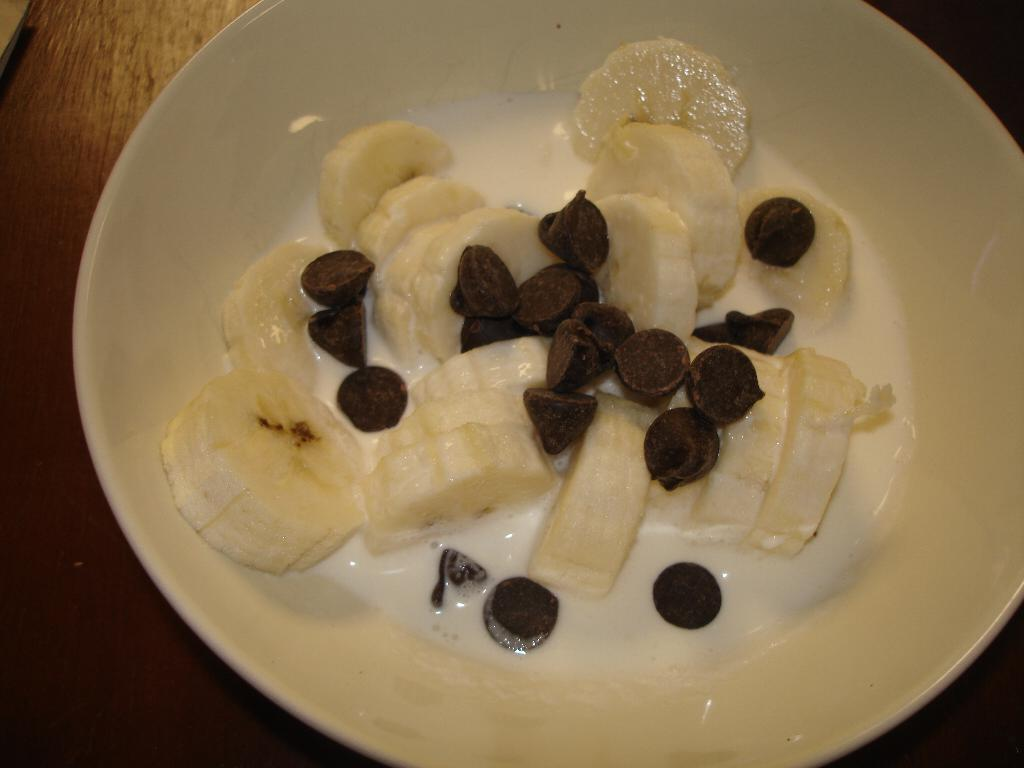What is in the bowl that is visible in the image? The bowl contains sliced bananas, chocolate chips, and milk. Where is the bowl located in the image? The bowl is placed on a table. In what type of setting is the image taken? The image is taken in a room. How many boys are present in the image? There are no boys present in the image; it only features a bowl with sliced bananas, chocolate chips, and milk on a table in a room. 